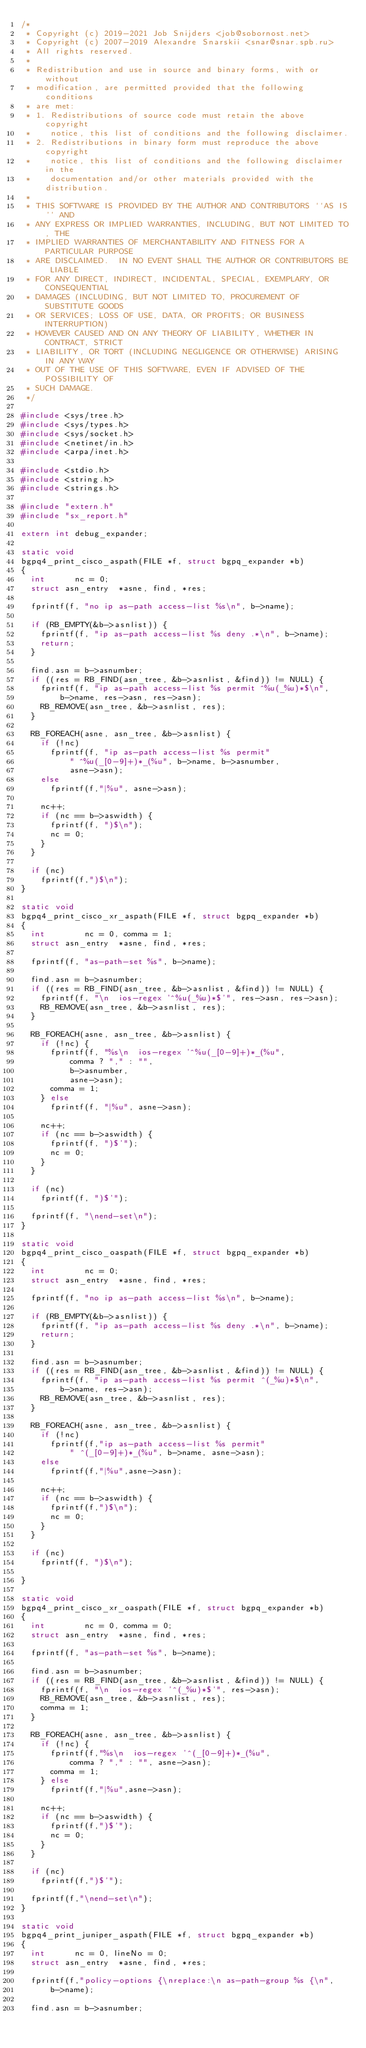<code> <loc_0><loc_0><loc_500><loc_500><_C_>/*
 * Copyright (c) 2019-2021 Job Snijders <job@sobornost.net>
 * Copyright (c) 2007-2019 Alexandre Snarskii <snar@snar.spb.ru>
 * All rights reserved.
 *
 * Redistribution and use in source and binary forms, with or without
 * modification, are permitted provided that the following conditions
 * are met:
 * 1. Redistributions of source code must retain the above copyright
 *    notice, this list of conditions and the following disclaimer.
 * 2. Redistributions in binary form must reproduce the above copyright
 *    notice, this list of conditions and the following disclaimer in the
 *    documentation and/or other materials provided with the distribution.
 *
 * THIS SOFTWARE IS PROVIDED BY THE AUTHOR AND CONTRIBUTORS ``AS IS'' AND
 * ANY EXPRESS OR IMPLIED WARRANTIES, INCLUDING, BUT NOT LIMITED TO, THE
 * IMPLIED WARRANTIES OF MERCHANTABILITY AND FITNESS FOR A PARTICULAR PURPOSE
 * ARE DISCLAIMED.  IN NO EVENT SHALL THE AUTHOR OR CONTRIBUTORS BE LIABLE
 * FOR ANY DIRECT, INDIRECT, INCIDENTAL, SPECIAL, EXEMPLARY, OR CONSEQUENTIAL
 * DAMAGES (INCLUDING, BUT NOT LIMITED TO, PROCUREMENT OF SUBSTITUTE GOODS
 * OR SERVICES; LOSS OF USE, DATA, OR PROFITS; OR BUSINESS INTERRUPTION)
 * HOWEVER CAUSED AND ON ANY THEORY OF LIABILITY, WHETHER IN CONTRACT, STRICT
 * LIABILITY, OR TORT (INCLUDING NEGLIGENCE OR OTHERWISE) ARISING IN ANY WAY
 * OUT OF THE USE OF THIS SOFTWARE, EVEN IF ADVISED OF THE POSSIBILITY OF
 * SUCH DAMAGE.
 */

#include <sys/tree.h>
#include <sys/types.h>
#include <sys/socket.h>
#include <netinet/in.h>
#include <arpa/inet.h>

#include <stdio.h>
#include <string.h>
#include <strings.h>

#include "extern.h"
#include "sx_report.h"

extern int debug_expander;

static void 
bgpq4_print_cisco_aspath(FILE *f, struct bgpq_expander *b)
{
	int			 nc = 0;
	struct asn_entry	*asne, find, *res;

	fprintf(f, "no ip as-path access-list %s\n", b->name);

	if (RB_EMPTY(&b->asnlist)) {
		fprintf(f, "ip as-path access-list %s deny .*\n", b->name);
		return;
	}

	find.asn = b->asnumber;
	if ((res = RB_FIND(asn_tree, &b->asnlist, &find)) != NULL) {
		fprintf(f, "ip as-path access-list %s permit ^%u(_%u)*$\n",
		    b->name, res->asn, res->asn);
		RB_REMOVE(asn_tree, &b->asnlist, res);
	}

	RB_FOREACH(asne, asn_tree, &b->asnlist) {
		if (!nc)
			fprintf(f, "ip as-path access-list %s permit"
			    " ^%u(_[0-9]+)*_(%u", b->name, b->asnumber,
			    asne->asn);
		else
			fprintf(f,"|%u", asne->asn);

		nc++;
		if (nc == b->aswidth) {
			fprintf(f, ")$\n");
			nc = 0;
		}
	}

	if (nc)
		fprintf(f,")$\n");
}

static void
bgpq4_print_cisco_xr_aspath(FILE *f, struct bgpq_expander *b)
{
	int 			 nc = 0, comma = 1;
	struct asn_entry	*asne, find, *res;

	fprintf(f, "as-path-set %s", b->name);

	find.asn = b->asnumber;
	if ((res = RB_FIND(asn_tree, &b->asnlist, &find)) != NULL) {
		fprintf(f, "\n  ios-regex '^%u(_%u)*$'", res->asn, res->asn);
		RB_REMOVE(asn_tree, &b->asnlist, res);
	}

	RB_FOREACH(asne, asn_tree, &b->asnlist) {
		if (!nc) {
			fprintf(f, "%s\n  ios-regex '^%u(_[0-9]+)*_(%u",
			    comma ? "," : "",
			    b->asnumber,
			    asne->asn);
			comma = 1;
		} else
			fprintf(f, "|%u", asne->asn);

		nc++;
		if (nc == b->aswidth) {
			fprintf(f, ")$'");
			nc = 0;
		}
	}

	if (nc)
		fprintf(f, ")$'");

	fprintf(f, "\nend-set\n");
}

static void
bgpq4_print_cisco_oaspath(FILE *f, struct bgpq_expander *b)
{
	int 			 nc = 0;
	struct asn_entry	*asne, find, *res;

	fprintf(f, "no ip as-path access-list %s\n", b->name);

	if (RB_EMPTY(&b->asnlist)) {
		fprintf(f, "ip as-path access-list %s deny .*\n", b->name);
		return;
	}

	find.asn = b->asnumber;
	if ((res = RB_FIND(asn_tree, &b->asnlist, &find)) != NULL) {
		fprintf(f, "ip as-path access-list %s permit ^(_%u)*$\n",
		    b->name, res->asn);
		RB_REMOVE(asn_tree, &b->asnlist, res);
	}

	RB_FOREACH(asne, asn_tree, &b->asnlist) {
		if (!nc)
			fprintf(f,"ip as-path access-list %s permit"
			    " ^(_[0-9]+)*_(%u", b->name, asne->asn);
		else
			fprintf(f,"|%u",asne->asn);

		nc++;
		if (nc == b->aswidth) {
			fprintf(f,")$\n");
			nc = 0;
		}
	}

	if (nc)
		fprintf(f, ")$\n");

}

static void
bgpq4_print_cisco_xr_oaspath(FILE *f, struct bgpq_expander *b)
{
	int 			 nc = 0, comma = 0;
	struct asn_entry	*asne, find, *res;

	fprintf(f, "as-path-set %s", b->name);

	find.asn = b->asnumber;
	if ((res = RB_FIND(asn_tree, &b->asnlist, &find)) != NULL) {
		fprintf(f, "\n  ios-regex '^(_%u)*$'", res->asn);
		RB_REMOVE(asn_tree, &b->asnlist, res);
		comma = 1;
	}

	RB_FOREACH(asne, asn_tree, &b->asnlist) {
		if (!nc) {
			fprintf(f,"%s\n  ios-regex '^(_[0-9]+)*_(%u",
			    comma ? "," : "", asne->asn);
			comma = 1;
		} else
			fprintf(f,"|%u",asne->asn);

		nc++;
		if (nc == b->aswidth) {
			fprintf(f,")$'");
			nc = 0;
		}
	}

	if (nc)
		fprintf(f,")$'");

	fprintf(f,"\nend-set\n");
}

static void
bgpq4_print_juniper_aspath(FILE *f, struct bgpq_expander *b)
{
	int			 nc = 0, lineNo = 0;
	struct asn_entry	*asne, find, *res;

	fprintf(f,"policy-options {\nreplace:\n as-path-group %s {\n",
	    b->name);

	find.asn = b->asnumber;</code> 